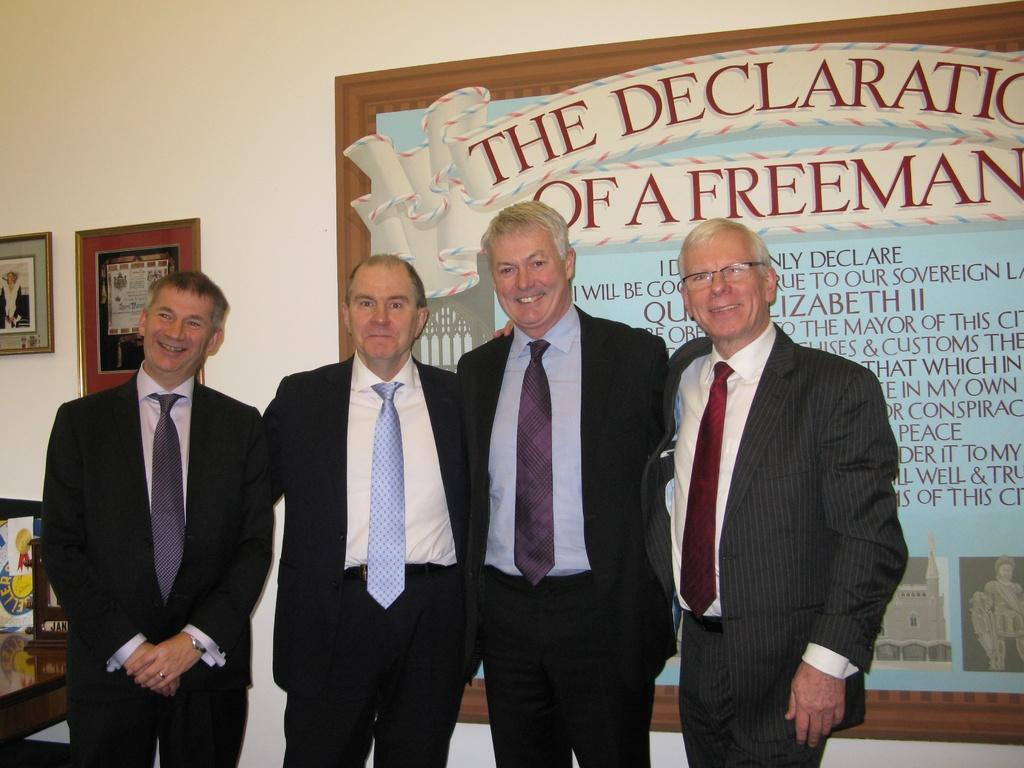How many men are in the image? There are 4 men in the image. What are the men wearing? The men are wearing suits. What is located on the left side of the image? There is a suit on the left side of the image. What can be seen in the background of the image? There are photo frames visible in the background of the image. What type of discovery did the men make while wearing spy outfits in the tent? There is no tent, discovery, or spy outfits present in the image. The men are wearing suits and there is no indication of any discovery or spy-related activities. 